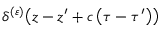<formula> <loc_0><loc_0><loc_500><loc_500>\delta ^ { ( \varepsilon ) } \, \left ( z - z ^ { \prime } + c \left ( \tau - \tau ^ { \prime } \right ) \right )</formula> 